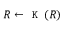<formula> <loc_0><loc_0><loc_500><loc_500>R \leftarrow K ( R )</formula> 